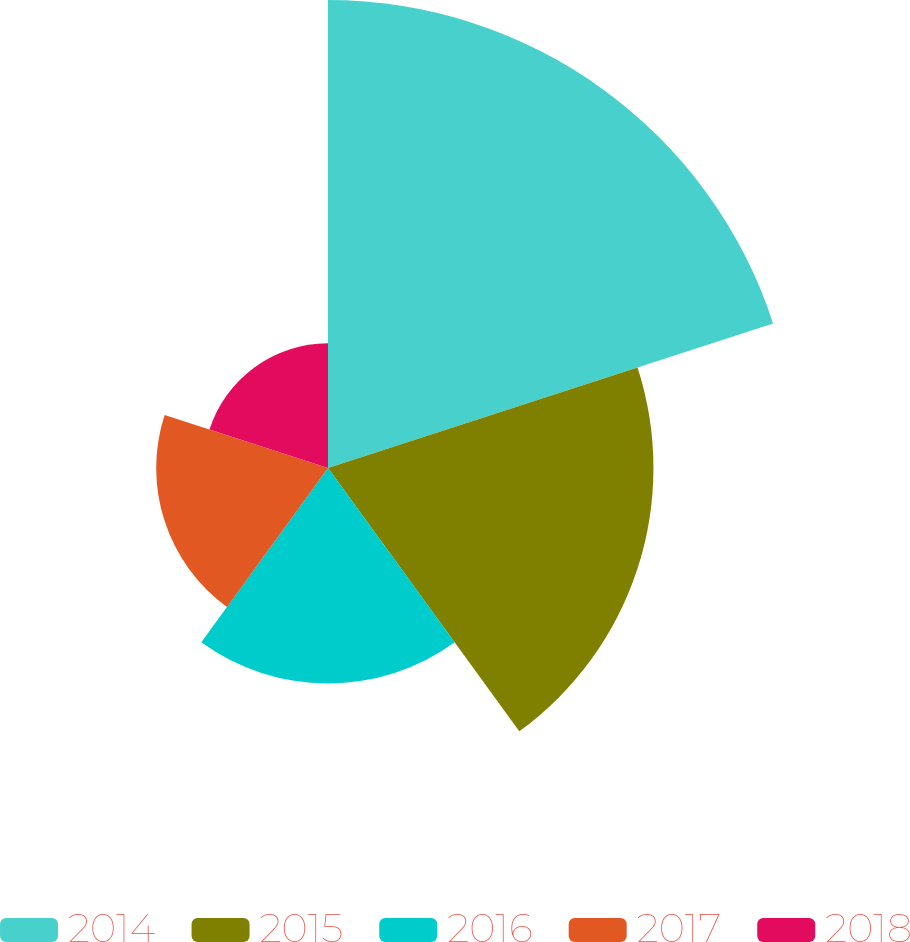Convert chart to OTSL. <chart><loc_0><loc_0><loc_500><loc_500><pie_chart><fcel>2014<fcel>2015<fcel>2016<fcel>2017<fcel>2018<nl><fcel>35.85%<fcel>24.93%<fcel>16.51%<fcel>13.16%<fcel>9.55%<nl></chart> 